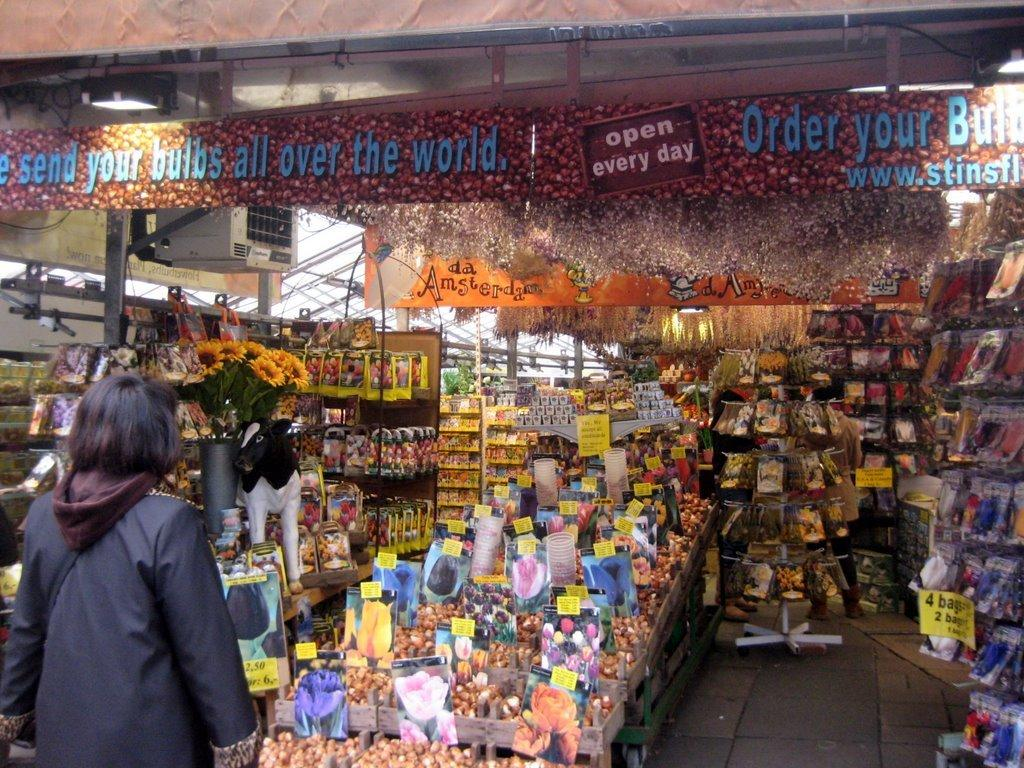<image>
Render a clear and concise summary of the photo. the inside of a store with a banner in it that says 'open every day' 